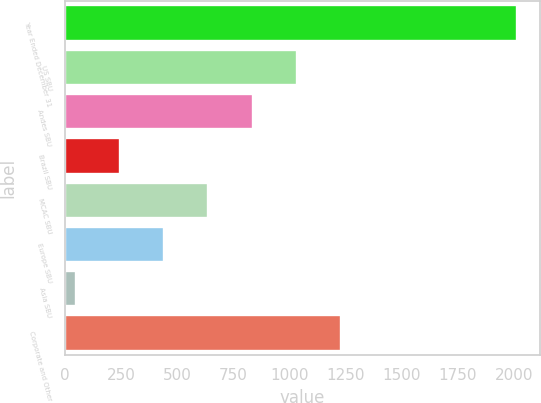Convert chart. <chart><loc_0><loc_0><loc_500><loc_500><bar_chart><fcel>Year Ended December 31<fcel>US SBU<fcel>Andes SBU<fcel>Brazil SBU<fcel>MCAC SBU<fcel>Europe SBU<fcel>Asia SBU<fcel>Corporate and Other<nl><fcel>2014<fcel>1031.4<fcel>834.8<fcel>245<fcel>638.2<fcel>441.6<fcel>48<fcel>1228<nl></chart> 